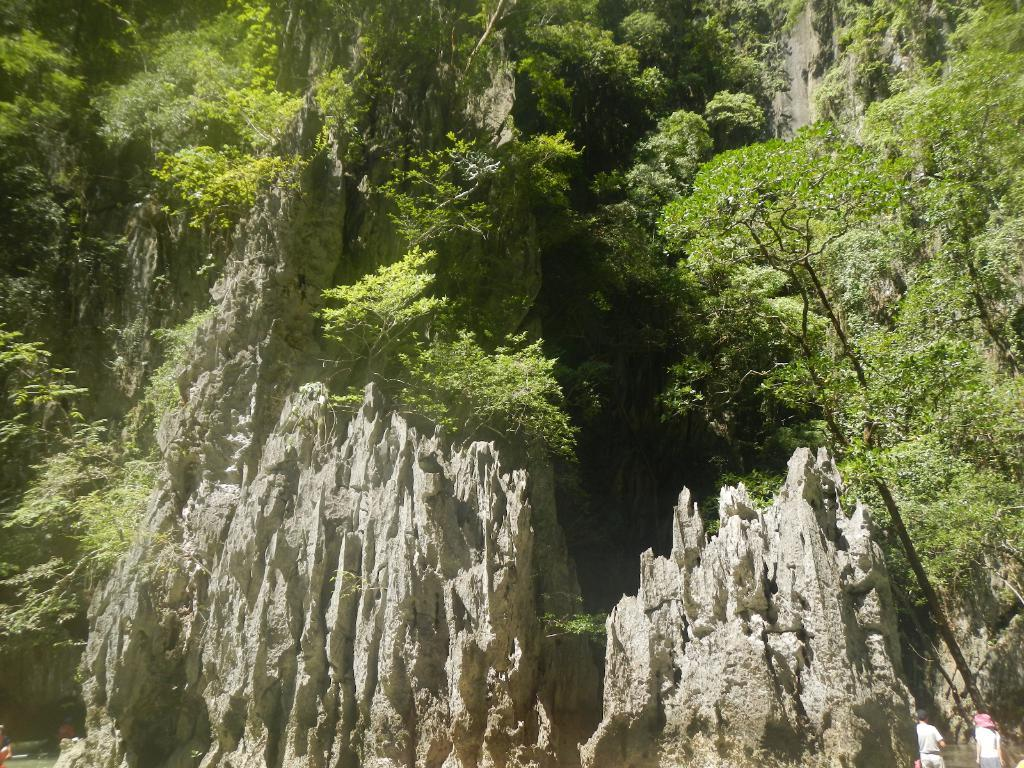What is the main feature in the center of the image? There are mountains and trees in the center of the image. Can you describe the mountains in the image? The mountains are visible in the center of the image. What other natural elements can be seen in the center of the image? There are trees in the center of the image. What type of yam is being used to decorate the trees in the image? There is no yam present in the image, and the trees are not being decorated. How many legs can be seen on the trees in the image? Trees do not have legs, so this question is not applicable to the image. 